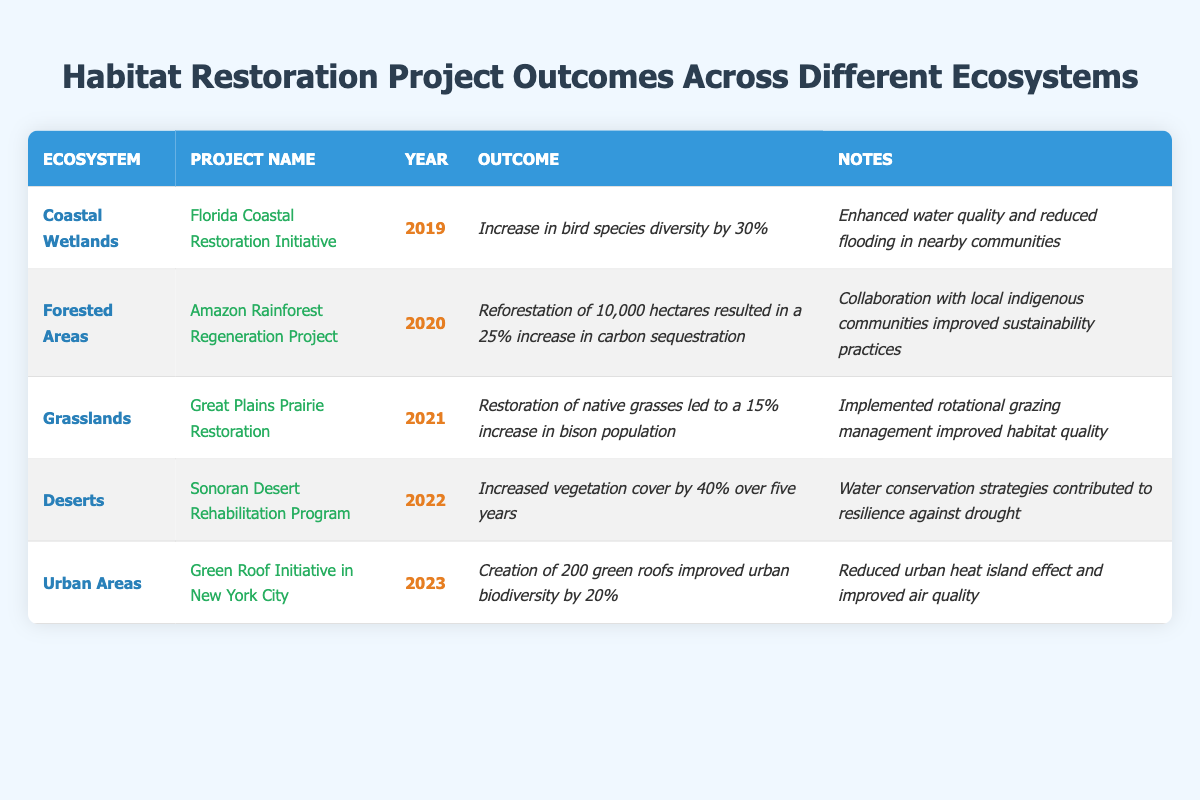What is the outcome of the Florida Coastal Restoration Initiative? The table lists the project name "Florida Coastal Restoration Initiative" under the "Project Name" column, and its corresponding outcome is mentioned as "Increase in bird species diversity by 30%."
Answer: Increase in bird species diversity by 30% Which ecosystem had the project with the greatest increase in vegetation cover? The "Sonoran Desert Rehabilitation Program" under the "Deserts" ecosystem shows an increase in vegetation cover by 40%. This is the highest among all projects in the table.
Answer: Deserts How many hectares were reforested in the Amazon Rainforest Regeneration Project? The table indicates that "Reforestation of 10,000 hectares" is a part of the "Amazon Rainforest Regeneration Project." Therefore, the number of hectares reforested is 10,000.
Answer: 10,000 hectares Which project improved urban biodiversity and by what percentage? The "Green Roof Initiative in New York City" enhanced urban biodiversity by 20%, as stated in the "Outcome" column.
Answer: 20% Did any project involve collaboration with indigenous communities? The "Amazon Rainforest Regeneration Project" notes collaboration with local indigenous communities, indicating this project involved such cooperation.
Answer: Yes What was the year with the lowest increase in population based on the projects? The project with the lowest percentage increase in population is the "Great Plains Prairie Restoration," which resulted in a 15% increase in the bison population in 2021.
Answer: 2021 What common goal did the projects across all ecosystems aim for? All these projects aimed to restore habitats, enhance biodiversity, improve ecosystem services, or increase vegetation cover, as reflected in their outcomes and notes.
Answer: Habitat restoration Calculate the total percentage increase in biodiversity from the Coastal Wetlands and Urban Areas projects. The Coastal Wetlands project increased bird species diversity by 30%, and the Urban Areas project improved biodiversity by 20%. Their total percentage increase is 30% + 20% = 50%.
Answer: 50% What is the difference in the year between the Amazon Rainforest Regeneration Project and the Green Roof Initiative? The Amazon Rainforest Regeneration Project occurred in 2020, while the Green Roof Initiative took place in 2023. The difference in years is 2023 - 2020 = 3 years.
Answer: 3 years Which project mentioned a strategy for resilience against drought? The "Sonoran Desert Rehabilitation Program" explicitly notes that "Water conservation strategies contributed to resilience against drought."
Answer: Sonoran Desert Rehabilitation Program 